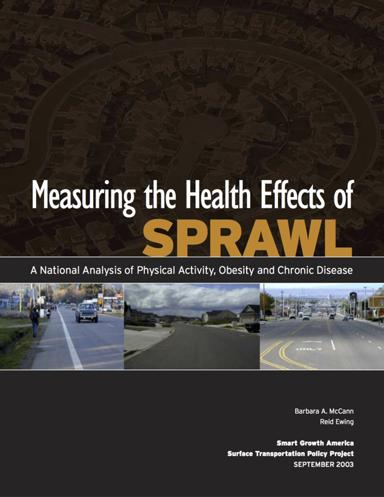Which organizations are involved in the publication of the brochure? The brochure is a collaborative publication, brought to you by Smart Growth America and the Surface Transportation Policy Project, both of which are key organizations advocating for sustainable urban development and transportation policies. 